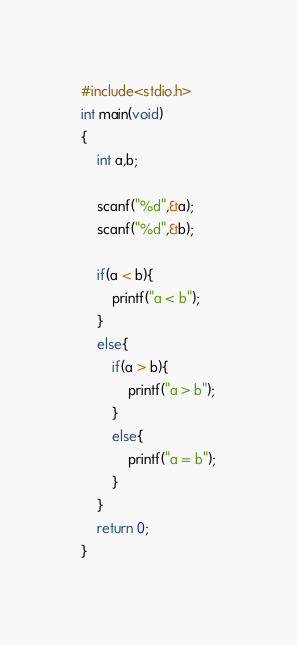Convert code to text. <code><loc_0><loc_0><loc_500><loc_500><_C_>#include<stdio.h>
int main(void)
{
	int a,b;
	
	scanf("%d",&a);
	scanf("%d",&b);
	
	if(a < b){
		printf("a < b");
	}
	else{
		if(a > b){
			printf("a > b");
		}
		else{
			printf("a = b");
		}
	}
	return 0;
}</code> 